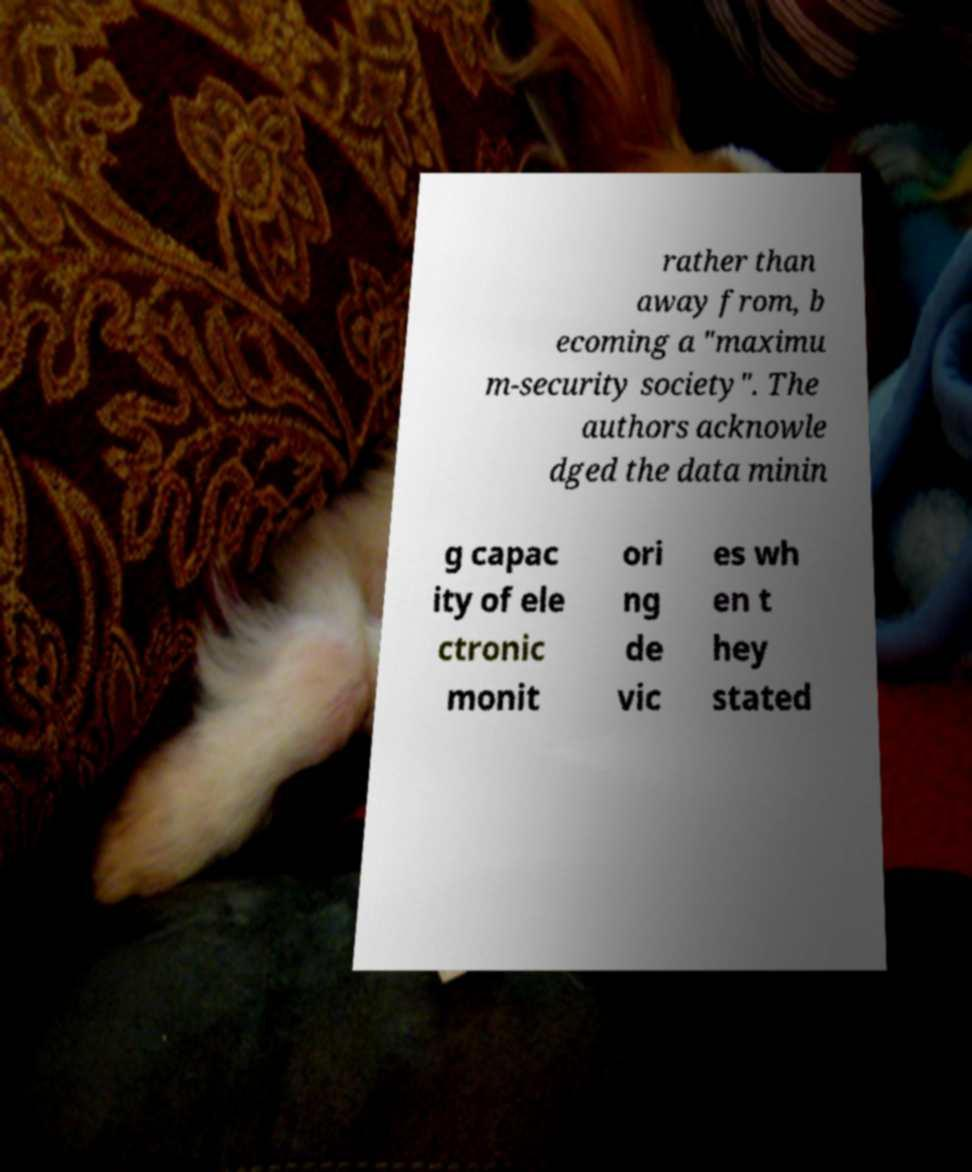Please read and relay the text visible in this image. What does it say? rather than away from, b ecoming a "maximu m-security society". The authors acknowle dged the data minin g capac ity of ele ctronic monit ori ng de vic es wh en t hey stated 